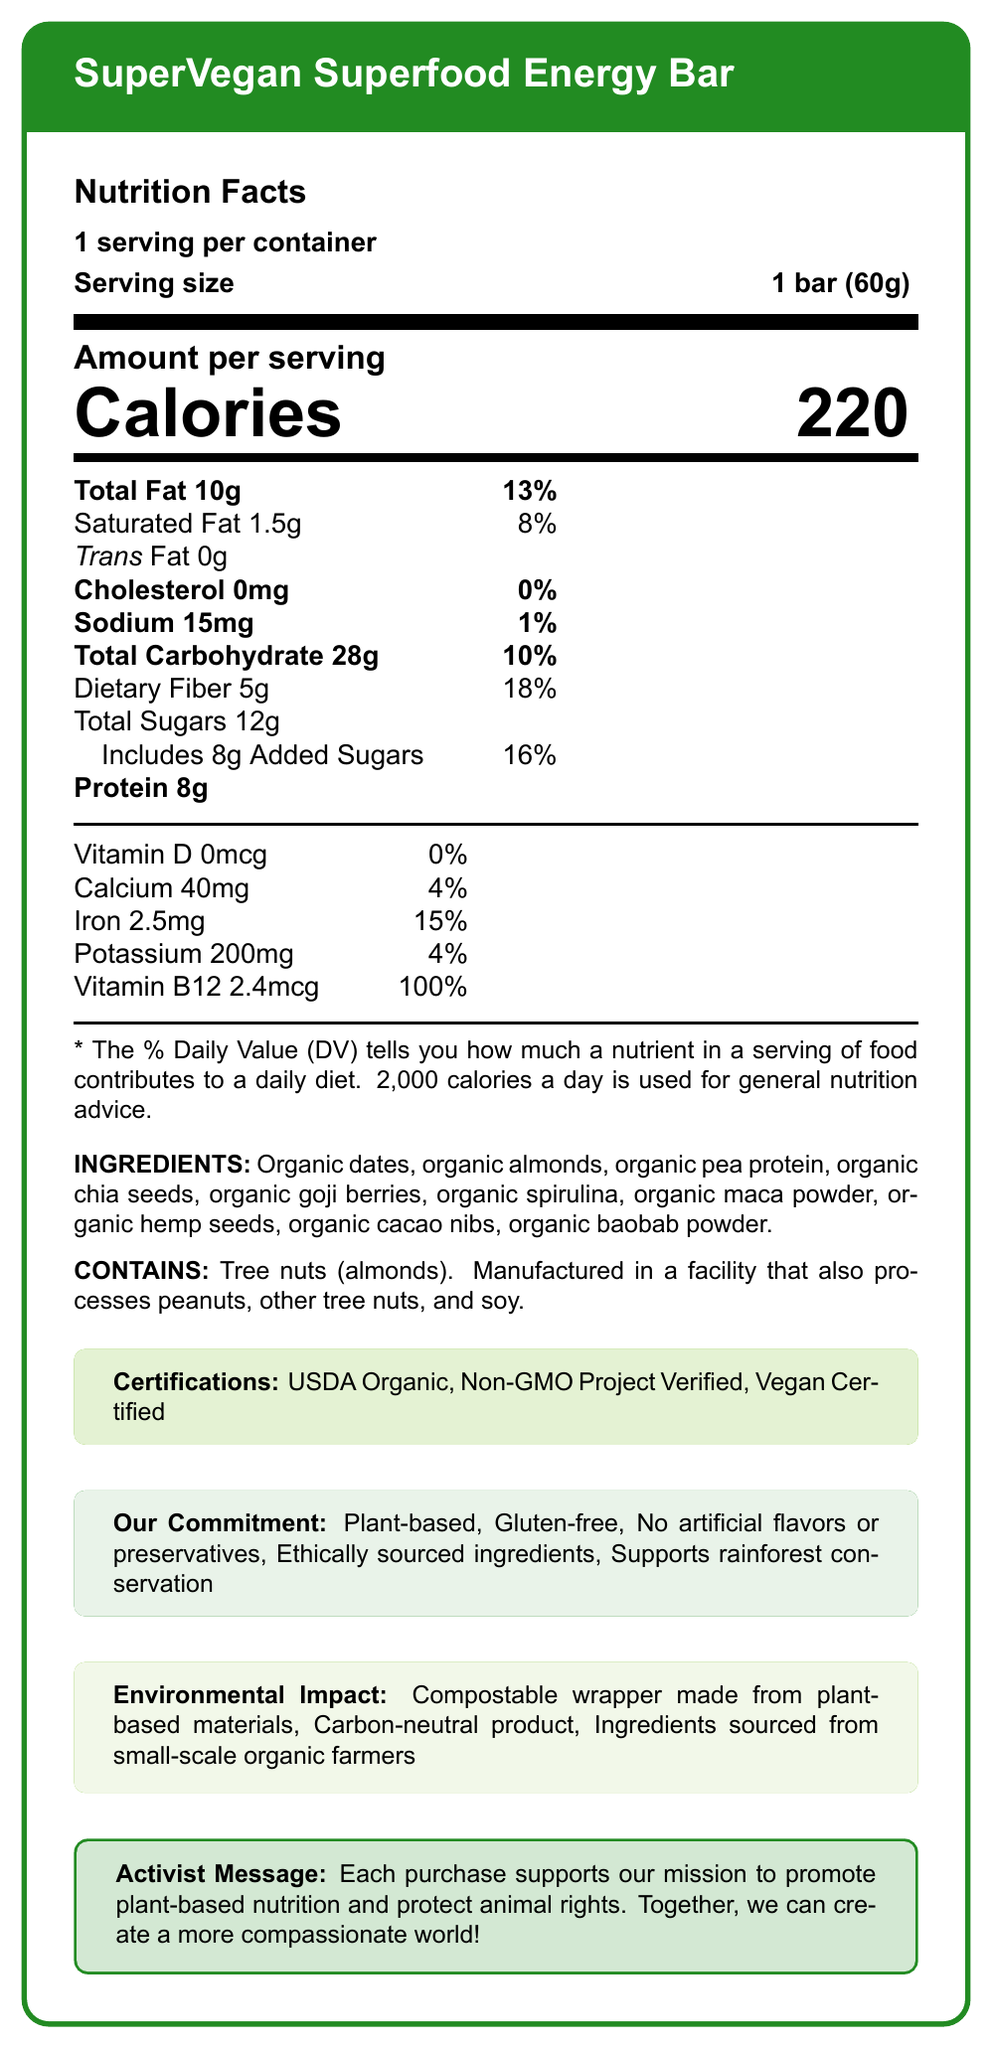what is the serving size of the SuperVegan Superfood Energy Bar? The serving size is clearly stated as "1 bar (60g)" in the document.
Answer: 1 bar (60g) how many calories does one serving of the energy bar contain? The document specifies that one serving contains 220 calories.
Answer: 220 what is the percentage of daily value for dietary fiber? According to the document, the dietary fiber content is 5g, which is 18% of the daily value.
Answer: 18% name three main ingredients of the SuperVegan Superfood Energy Bar. The document lists the ingredients, with the first three being organic dates, organic almonds, and organic pea protein.
Answer: Organic dates, Organic almonds, Organic pea protein what certifications does the SuperVegan Superfood Energy Bar have? The document states that the bar is USDA Organic, Non-GMO Project Verified, and Vegan Certified.
Answer: USDA Organic, Non-GMO Project Verified, Vegan Certified which vitamin has the highest percent daily value in the energy bar? A. Vitamin D B. Calcium C. Iron D. Vitamin B12 Vitamin B12 has 100% daily value, which is the highest among the vitamins listed.
Answer: D. Vitamin B12 how much sodium is present in one serving of the energy bar? A. 15mg B. 20mg C. 25mg D. 30mg The document indicates that there are 15mg of sodium per serving.
Answer: A. 15mg is the energy bar gluten-free? The document mentions that the bar is gluten-free under the "Our Commitment" section.
Answer: Yes does the energy bar contain any cholesterol? The document clearly states that the cholesterol content is 0mg, which means it contains no cholesterol.
Answer: No what is the environmental impact of the packaging for the energy bar? The document describes the packaging as compostable and made from plant-based materials.
Answer: Compostable wrapper made from plant-based materials describe the main purpose of the SuperVegan Superfood Energy Bar as stated in the document. The document highlights the bar's function as a nutritious, vegan energy source with ingredients sourced from small-scale organic farmers. It emphasizes plant-based nutrition and protection of animal rights, with ethical sourcing and carbon neutrality.
Answer: The main purpose of the SuperVegan Superfood Energy Bar is to provide a nutritious, vegan-friendly energy source with ethically sourced, organic ingredients, while also supporting plant-based nutrition and animal rights. The bar aims to promote health and compassion through its mission and environmental commitments. how many grams of added sugars are in the energy bar? The added sugars content is stated as 8g in the document.
Answer: 8g what is the protein content per serving in the energy bar? The protein content per serving is 8g, as indicated in the nutrition facts.
Answer: 8g how many servings are there per container? The document states that there is 1 serving per container.
Answer: 1 what is the iron content in one serving of the energy bar? The document lists the iron content as 2.5mg per serving.
Answer: 2.5mg what is the mission supported by the purchase of this energy bar? The activist message section of the document states that each purchase helps promote plant-based nutrition and protect animal rights.
Answer: To promote plant-based nutrition and protect animal rights. what percentage of the daily value is the saturated fat in the energy bar? The saturated fat content is 1.5g, which is 8% of the daily value according to the document.
Answer: 8% which facility processes this energy bar? The document indicates that the bar is manufactured in a facility that processes peanuts, other tree nuts, and soy.
Answer: Facility that also processes peanuts, other tree nuts, and soy where are the ingredients of the energy bar sourced from? The document describes the ingredients as being sourced from small-scale organic farmers.
Answer: Small-scale organic farmers is the energy bar carbon-neutral? The environmental impact section in the document states that the product is carbon-neutral.
Answer: Yes does the document specify the country of origin for the ingredients? The document does not provide specific information about the country of origin for the ingredients.
Answer: Not enough information 